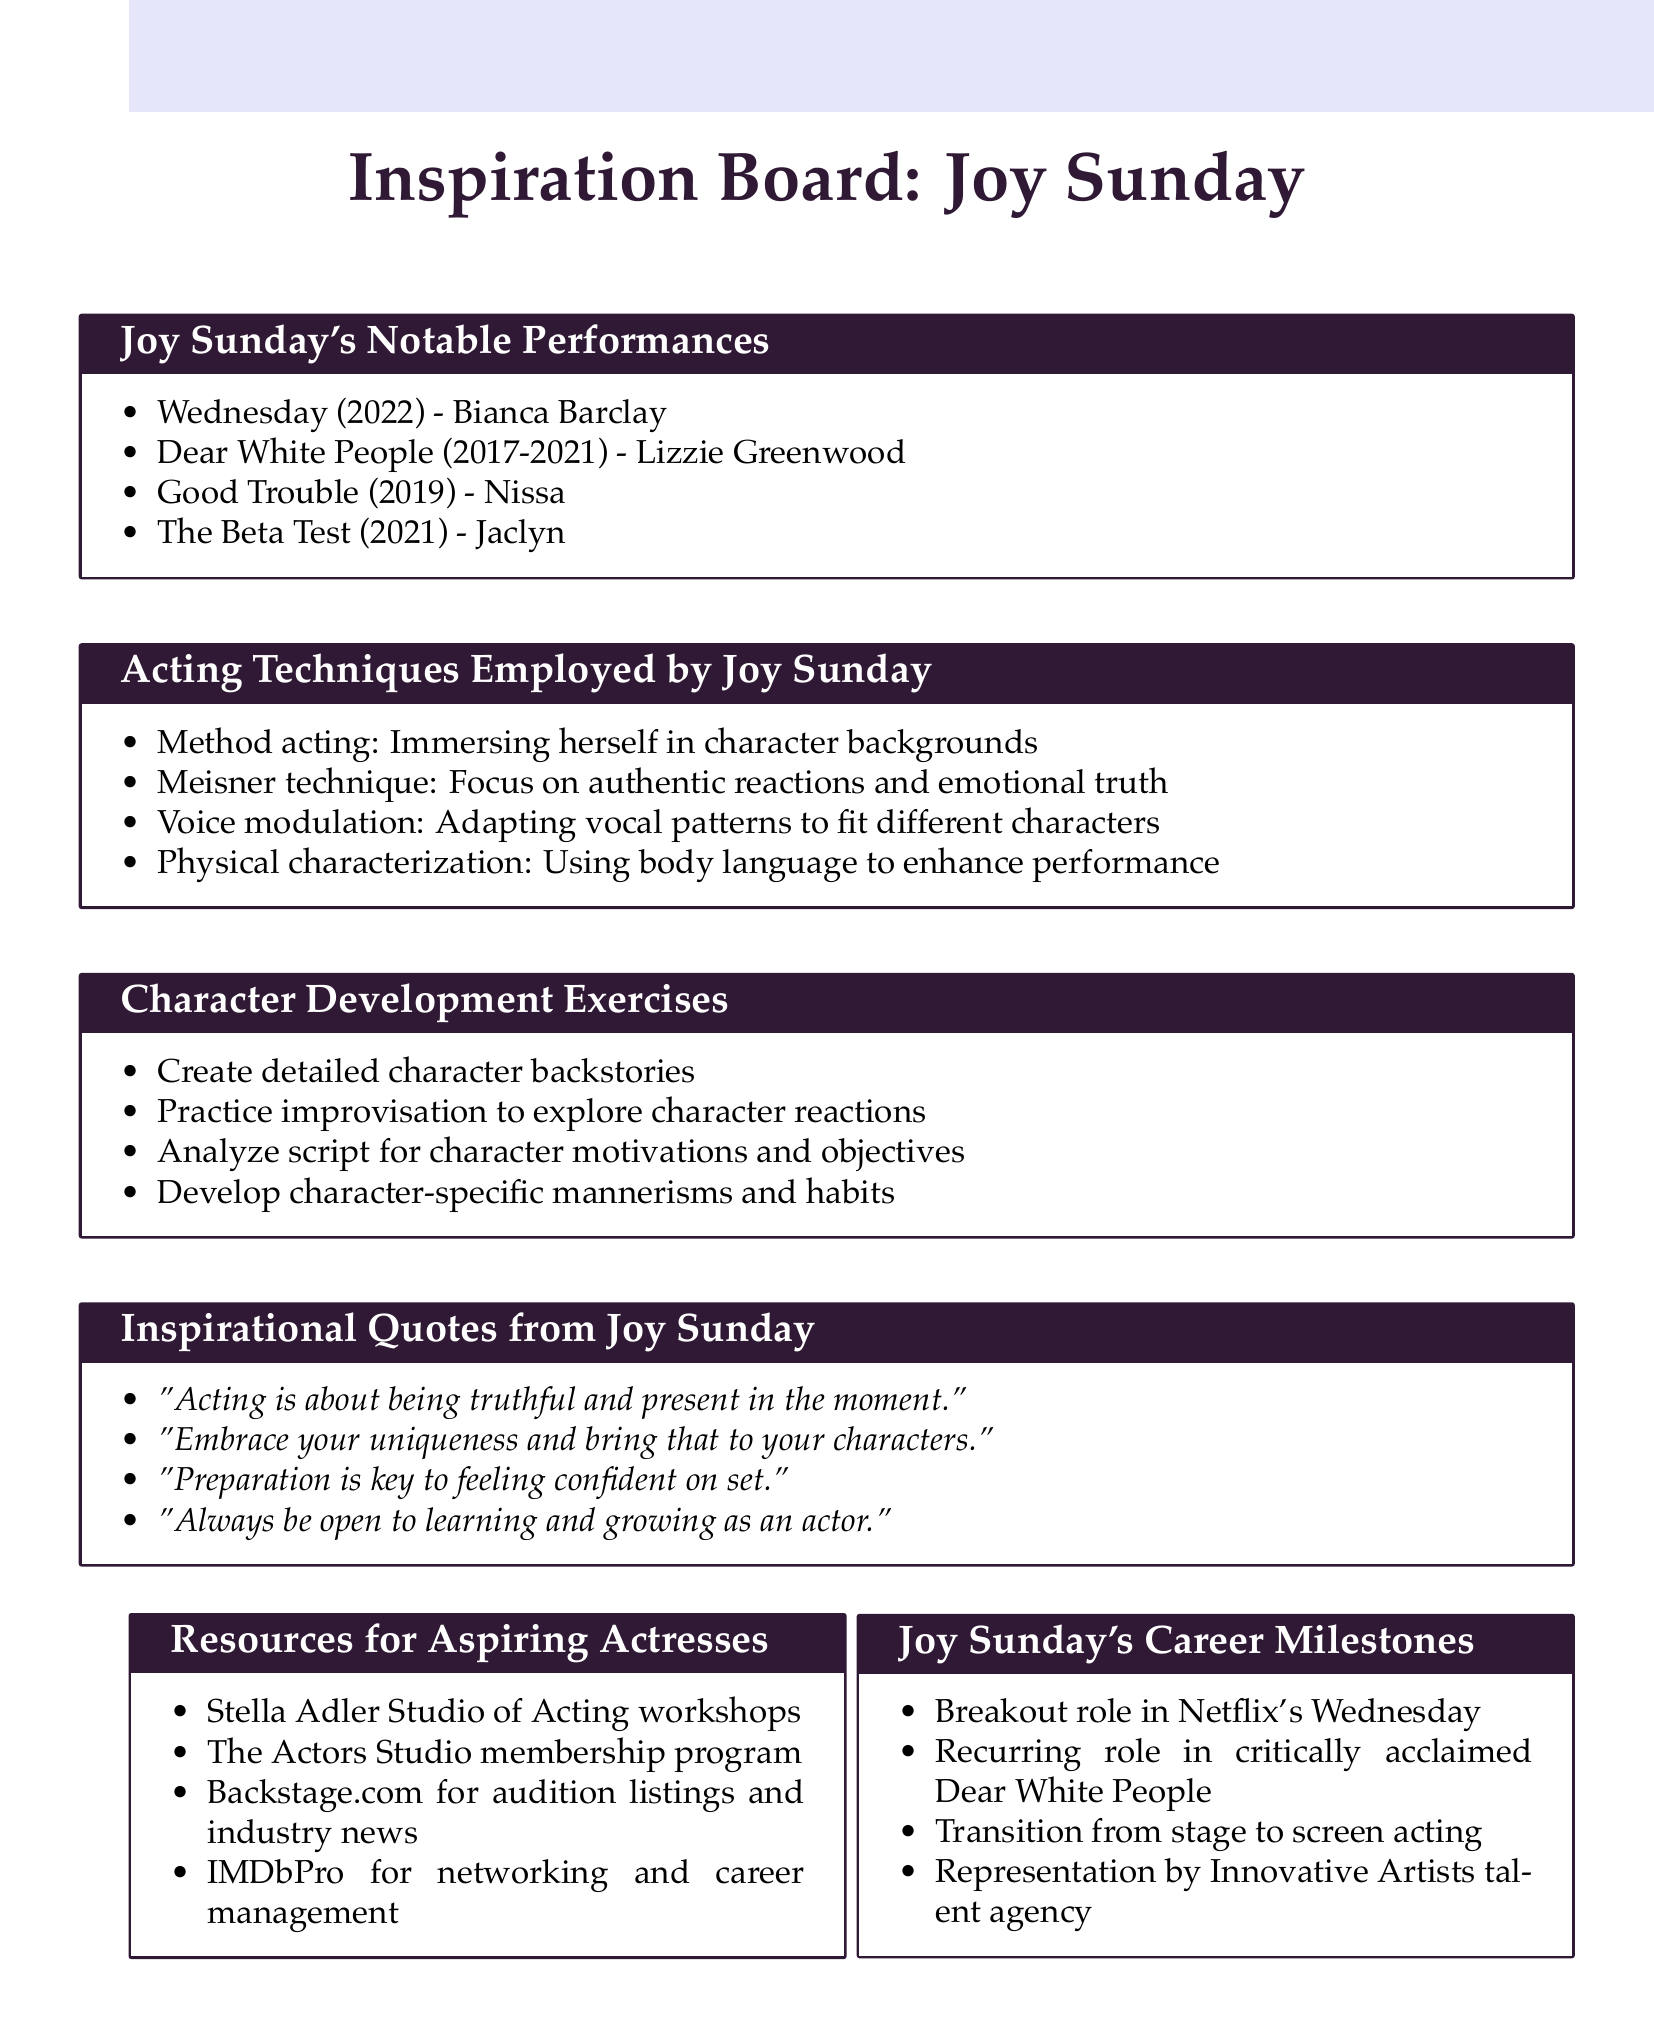What is Joy Sunday's breakout role? The breakout role is specifically mentioned in the document as part of her career milestones.
Answer: Netflix's Wednesday Which character did Joy Sunday play in "Dear White People"? The document provides the name of the character associated with the show "Dear White People".
Answer: Lizzie Greenwood How many acting techniques are listed for Joy Sunday? The document enumerates the acting techniques used by Joy Sunday, leading to a count.
Answer: Four What is one exercise for character development mentioned in the document? The document lists exercises under character development.
Answer: Create detailed character backstories What is an inspirational quote from Joy Sunday about acting? The document contains a section with quotes by Joy Sunday, focusing on her perspective regarding acting.
Answer: "Acting is about being truthful and present in the moment." Which acting studio offers workshops according to the resources section? The document cites specific resources for aspiring actresses, including acting studios.
Answer: Stella Adler Studio of Acting workshops What technique focuses on emotional truth as per Joy Sunday’s acting methods? The document describes various acting techniques, pinpointing the one that relates to emotional truth.
Answer: Meisner technique How many notable performances are listed for Joy Sunday? The document includes notable performances in a categorized list, allowing for a total count.
Answer: Four 